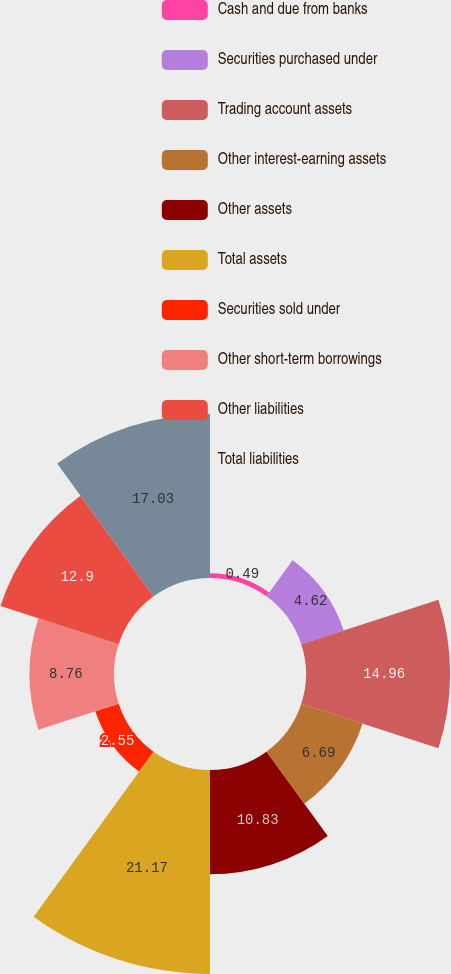<chart> <loc_0><loc_0><loc_500><loc_500><pie_chart><fcel>Cash and due from banks<fcel>Securities purchased under<fcel>Trading account assets<fcel>Other interest-earning assets<fcel>Other assets<fcel>Total assets<fcel>Securities sold under<fcel>Other short-term borrowings<fcel>Other liabilities<fcel>Total liabilities<nl><fcel>0.49%<fcel>4.62%<fcel>14.96%<fcel>6.69%<fcel>10.83%<fcel>21.17%<fcel>2.55%<fcel>8.76%<fcel>12.9%<fcel>17.03%<nl></chart> 